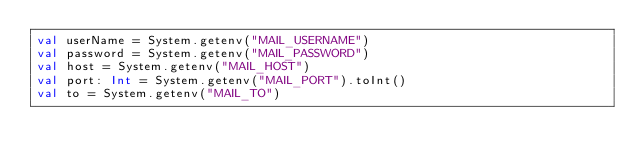<code> <loc_0><loc_0><loc_500><loc_500><_Kotlin_>val userName = System.getenv("MAIL_USERNAME")
val password = System.getenv("MAIL_PASSWORD")
val host = System.getenv("MAIL_HOST")
val port: Int = System.getenv("MAIL_PORT").toInt()
val to = System.getenv("MAIL_TO")</code> 